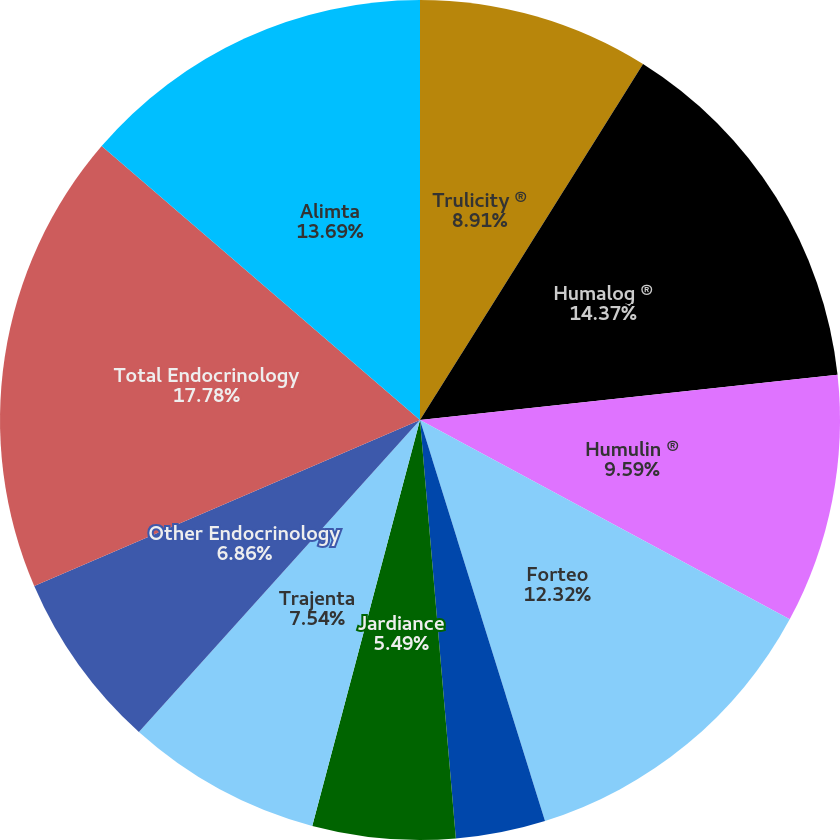Convert chart. <chart><loc_0><loc_0><loc_500><loc_500><pie_chart><fcel>Trulicity ®<fcel>Humalog ®<fcel>Humulin ®<fcel>Forteo<fcel>Basaglar<fcel>Jardiance<fcel>Trajenta<fcel>Other Endocrinology<fcel>Total Endocrinology<fcel>Alimta<nl><fcel>8.91%<fcel>14.37%<fcel>9.59%<fcel>12.32%<fcel>3.45%<fcel>5.49%<fcel>7.54%<fcel>6.86%<fcel>17.78%<fcel>13.69%<nl></chart> 